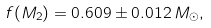<formula> <loc_0><loc_0><loc_500><loc_500>f ( M _ { 2 } ) = 0 . 6 0 9 \pm 0 . 0 1 2 \, M _ { \odot } ,</formula> 